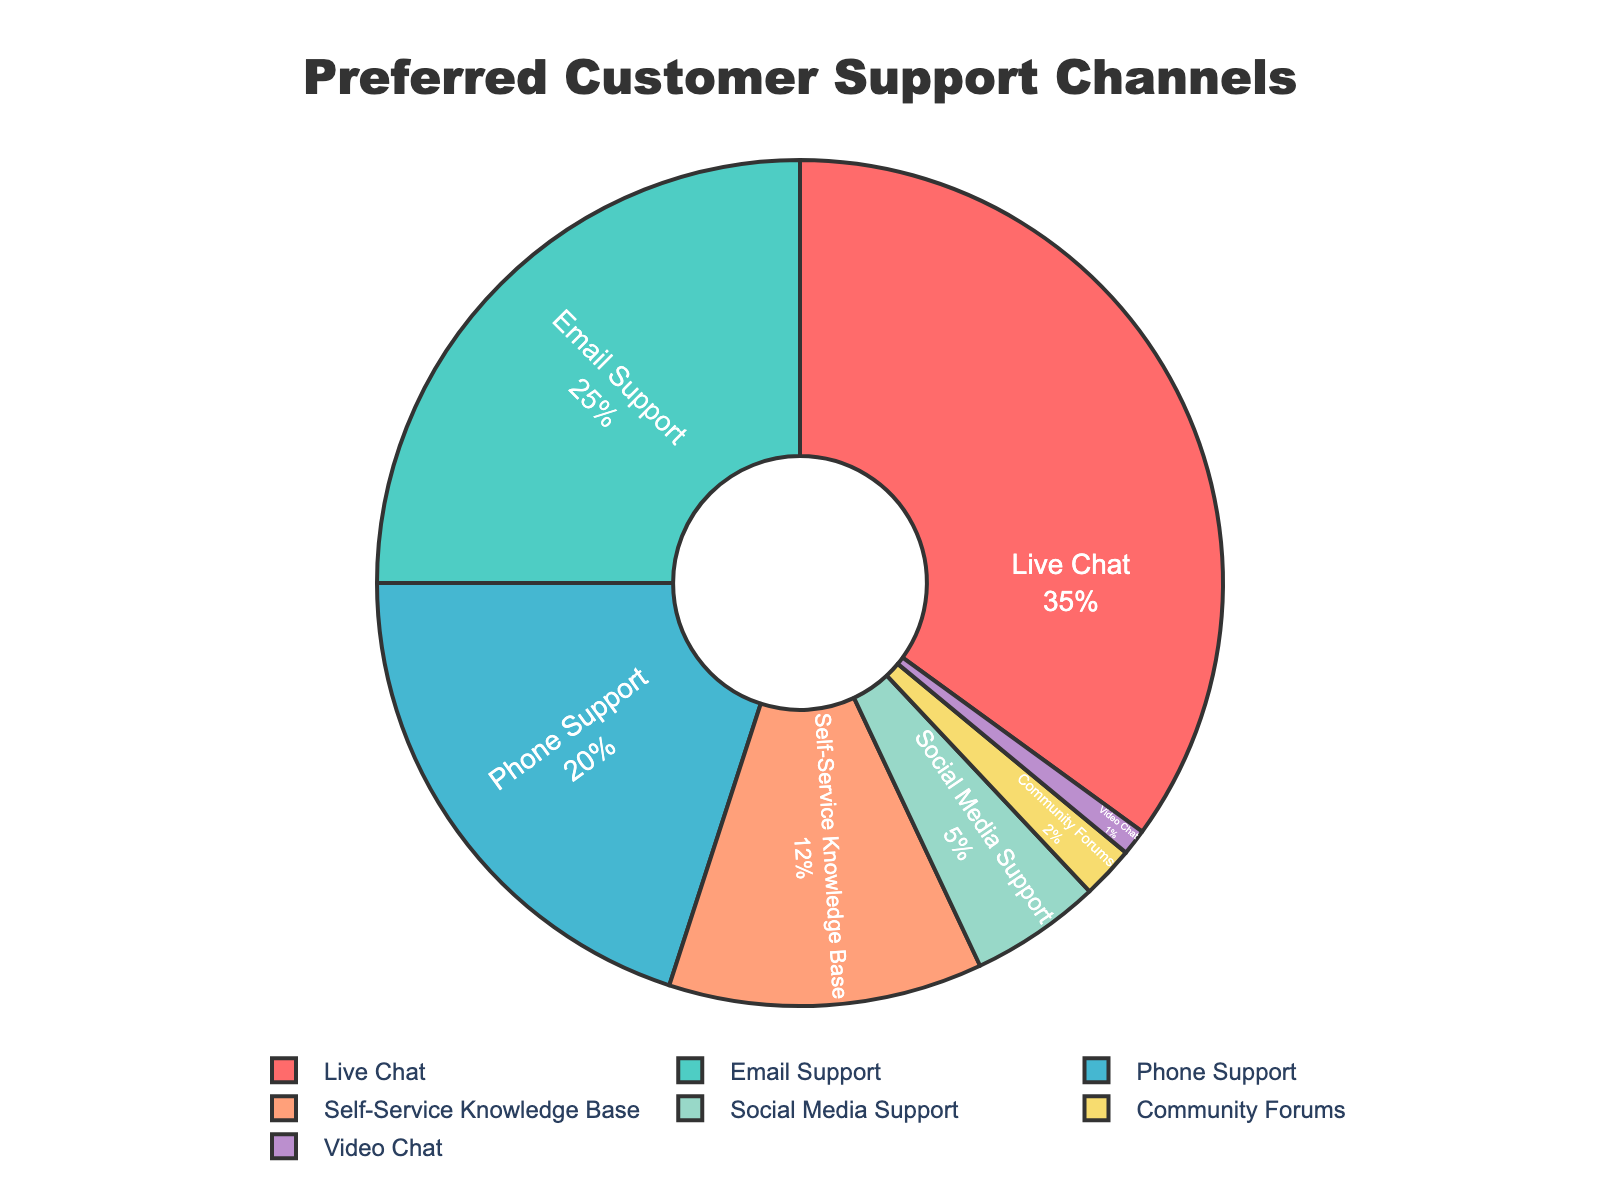What percentage of users prefer real-time support methods (Live Chat, Phone Support, Video Chat)? Add the percentages of Live Chat (35%), Phone Support (20%), and Video Chat (1%): 35 + 20 + 1 = 56%.
Answer: 56% Which support method is preferred by the smallest percentage of users? Looking at the percentages, Video Chat has the smallest percentage (1%).
Answer: Video Chat Compare the preference between Email Support and Self-Service Knowledge Base. Which one is preferred more and by how much? Email Support has 25% and Self-Service Knowledge Base has 12%. The difference is 25 - 12 = 13%.
Answer: Email Support by 13% What is the combined percentage of users who prefer non-real-time support methods (Email Support, Self-Service Knowledge Base, Social Media Support, Community Forums)? Add the percentages of Email Support (25%), Self-Service Knowledge Base (12%), Social Media Support (5%), and Community Forums (2%): 25 + 12 + 5 + 2 = 44%.
Answer: 44% How much more popular is Live Chat compared to Social Media Support? Live Chat has 35% and Social Media Support has 5%. The difference is 35 - 5 = 30%.
Answer: 30% What color represents the Email Support section in the pie chart? The pie chart colors Email Support with a greenish color (#4ECDC4).
Answer: Greenish What's the total percentage covered by Phone Support and Community Forums? Add the percentages of Phone Support (20%) and Community Forums (2%): 20 + 2 = 22%.
Answer: 22% Which support method ranks third in terms of user preference? Live Chat (35%) is first, Email Support (25%) is second, and Phone Support (20%) is third.
Answer: Phone Support 